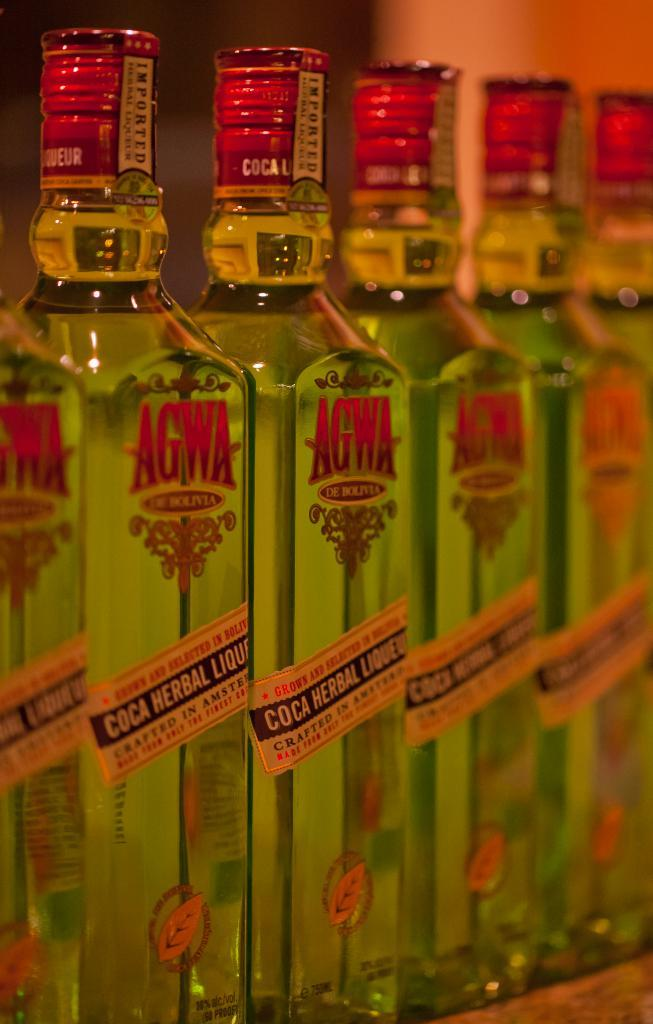What is the main subject of the picture? The main subject of the picture is bottles. What is written on the bottles? The bottles are named "AGWA". What type of cakes are being discussed in the image? There is no discussion or cakes present in the image; it features bottles named "AGWA". Can you see a guitar in the image? There is no guitar present in the image; it only features bottles named "AGWA". 